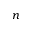<formula> <loc_0><loc_0><loc_500><loc_500>n</formula> 